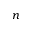<formula> <loc_0><loc_0><loc_500><loc_500>n</formula> 